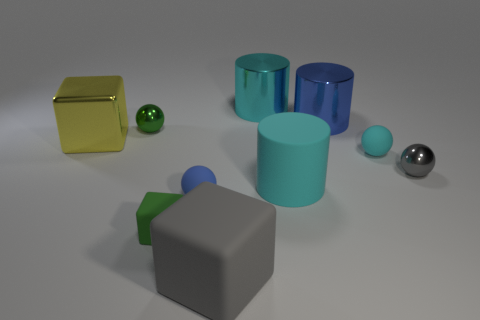Subtract all cylinders. How many objects are left? 7 Add 9 brown metallic spheres. How many brown metallic spheres exist? 9 Subtract 2 cyan cylinders. How many objects are left? 8 Subtract all metal cylinders. Subtract all green cubes. How many objects are left? 7 Add 6 tiny shiny things. How many tiny shiny things are left? 8 